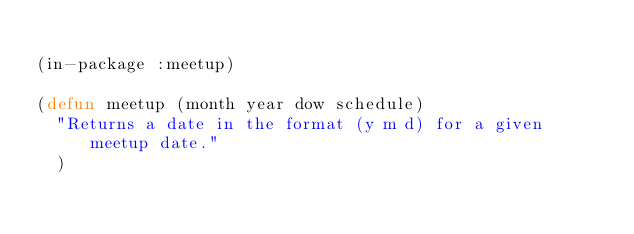Convert code to text. <code><loc_0><loc_0><loc_500><loc_500><_Lisp_>
(in-package :meetup)

(defun meetup (month year dow schedule)
  "Returns a date in the format (y m d) for a given meetup date."
  )
</code> 